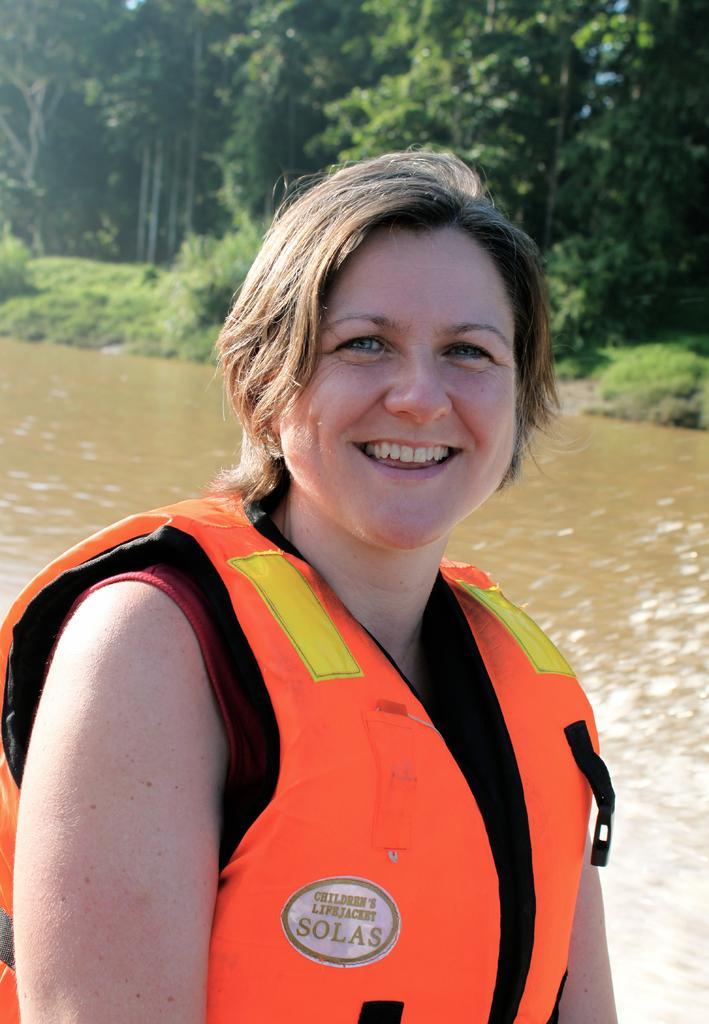Could you give a brief overview of what you see in this image? In this image, we can see a lady, plants and trees. We can also see some water. 